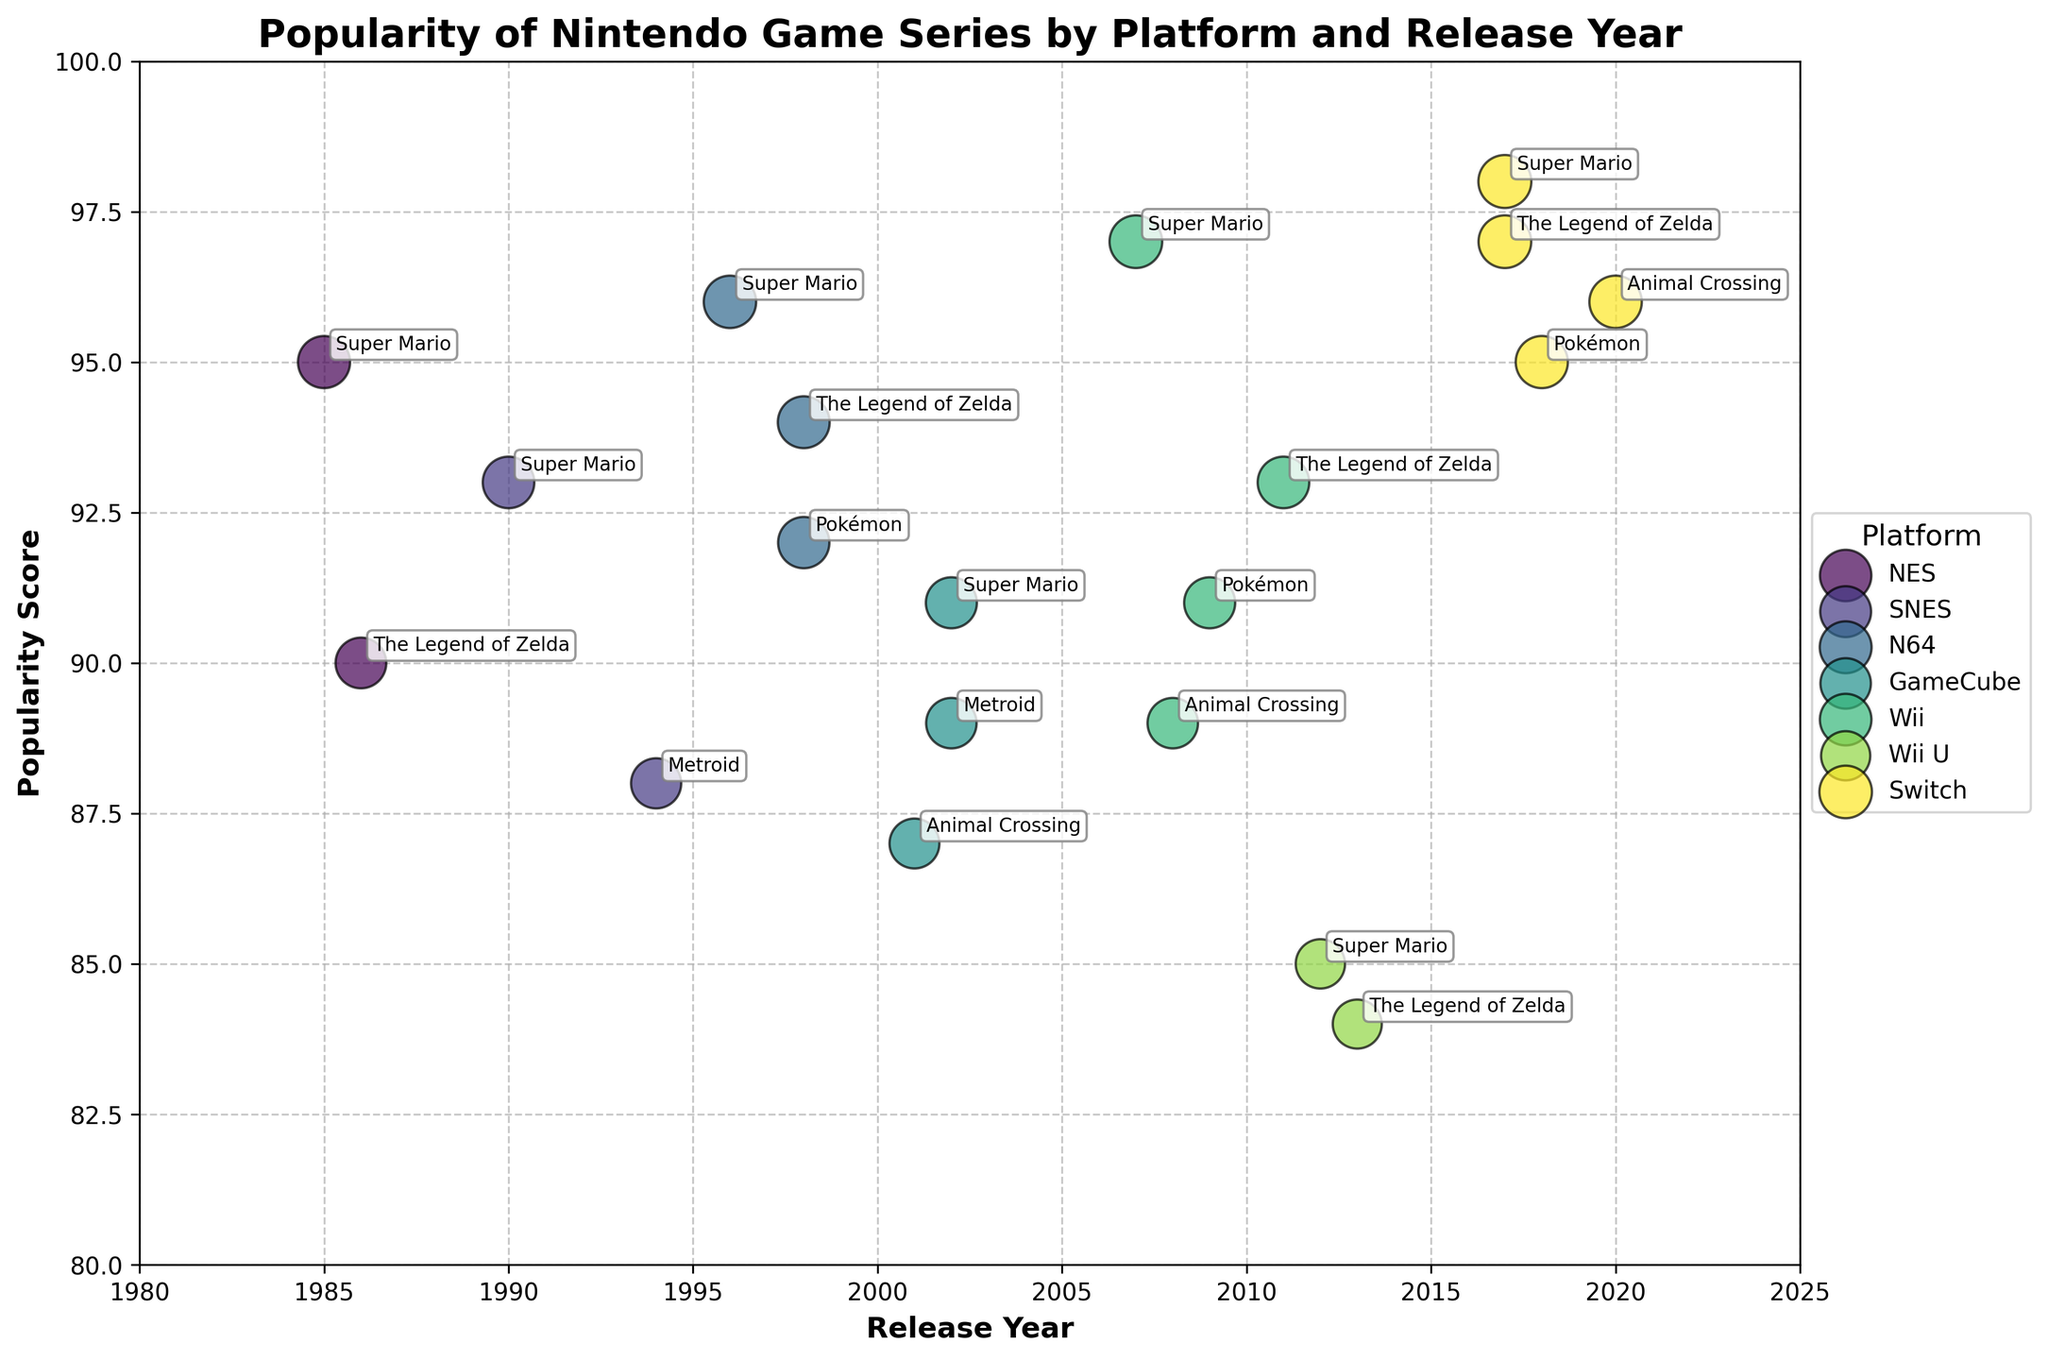what is the highest popularity score achieved by a Nintendo game series on the Switch? The figure shows the popularity scores for different Nintendo game series by platform. Look for the Switch platform and identify the highest popularity score among its data points. The highest score for the Switch is 98, achieved by Super Mario in 2017.
Answer: 98 which platform had the most game series released between 2000 and 2010? Observe the release years for each platform and count the number of game series released within the 2000-2010 range. The GameCube has the most game series released in this period, with four game series.
Answer: GameCube what is the average popularity score of Super Mario across all platforms? Identify the popularity scores of Super Mario on all platforms, then calculate the average. Super Mario's scores are 95 (NES), 93 (SNES), 96 (N64), 91 (GameCube), 97 (Wii), 85 (Wii U), and 98 (Switch). Sum these values: 95 + 93 + 96 + 91 + 97 + 85 + 98 = 655. There are 7 scores in total, hence the average is 655 / 7.
Answer: 93.6 which platform has the largest bubbles indicating higher popularity scores in recent years? The size of the bubbles represents popularity scores. Identify the platforms with large bubbles, focusing on recent years (closer to 2020). The Switch has larger bubbles (e.g., Super Mario 98, The Legend of Zelda 97, Animal Crossing 96) indicating higher popularity scores in recent years.
Answer: Switch how does the popularity score of Animal Crossing on the GameCube compare to the Wii? Locate the popularity scores of Animal Crossing on both the GameCube and Wii platforms. Compare the two values. Animal Crossing has a score of 87 on the GameCube and 89 on the Wii. Hence, it is slightly more popular on the Wii by 2 points.
Answer: Wii what is the overall trend in popularity scores of The Legend of Zelda series from NES to Switch? Identify the popularity scores of The Legend of Zelda series on each platform and arrange them chronologically to observe the trend. Scores are: NES (90), N64 (94), Wii (93), Wii U (84), and Switch (97). The trend shows an initial increase, a slight decline on the Wii U, and a significant increase on the Switch.
Answer: Increasing trend with a dip on Wii U which platform has the fewest game series represented in the chart? Count the number of game series for each platform represented in the chart. NES has 2 game series (Super Mario and The Legend of Zelda), which is the fewest.
Answer: NES what is the popularity score range of Metroid series across the different platforms? Identify the popularity scores of Metroid on the platforms where it appears and find the range. Metroid appears on SNES (88) and GameCube (89). The range is the difference between the highest and lowest scores, which is 89 - 88.
Answer: 1 